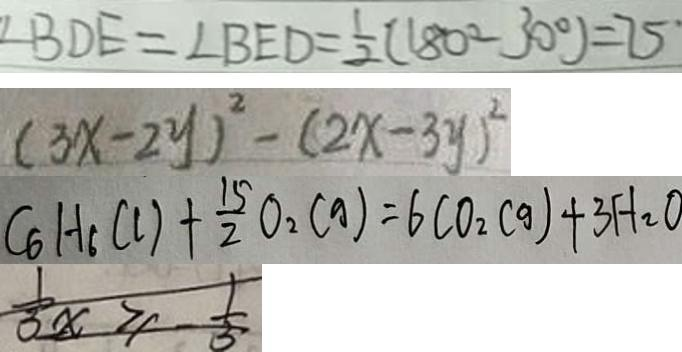Convert formula to latex. <formula><loc_0><loc_0><loc_500><loc_500>\angle B D E = \angle B E D = \frac { 1 } { 2 } ( 1 8 0 ^ { \circ } - 3 0 ^ { \circ } ) = 7 5 ^ { \circ } 
 ( 3 x - 2 y ) ^ { 2 } - ( 2 x - 3 y ) ^ { 2 } 
 C _ { 6 } H _ { 6 } ( l ) + \frac { 1 5 } { 2 } O _ { 2 } ( g ) = 6 C O _ { 2 } ( g ) + 3 H _ { 2 } O 
 \frac { 1 } { 3 } x \geq \frac { 1 } { 3 }</formula> 